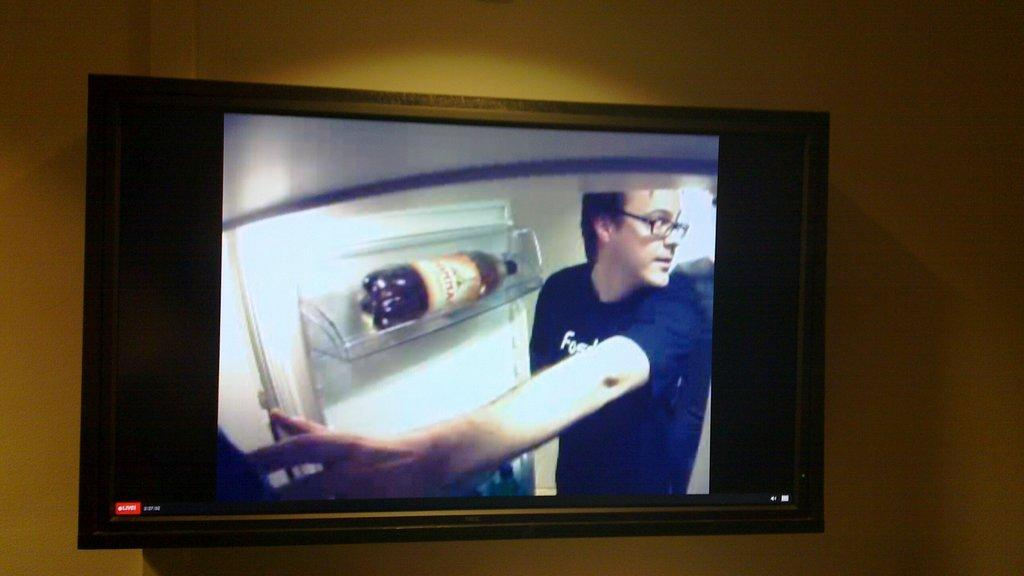What electronic device is present in the image? There is a television in the image. How is the television positioned in the image? The television is attached to the wall. What can be seen on the screen of the television? There is a person visible on the screen of the television. What type of appliance is present in the image, separate from the television? There is a refrigerator in the image. What is inside the refrigerator, as seen on the screen of the television? There is a bottle in the rack of the refrigerator on the screen of the television. What type of shirt is the person wearing on the screen of the television? There is no shirt visible on the person in the image, as we can only see their face on the screen of the television. 